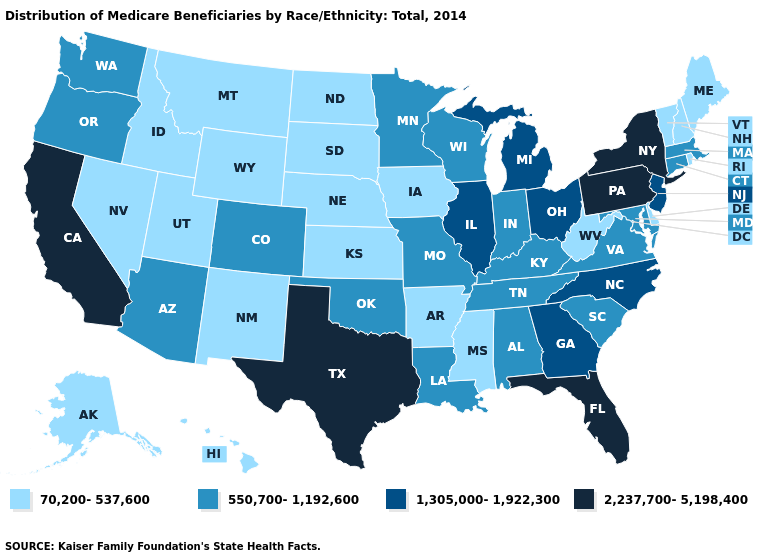Name the states that have a value in the range 70,200-537,600?
Give a very brief answer. Alaska, Arkansas, Delaware, Hawaii, Idaho, Iowa, Kansas, Maine, Mississippi, Montana, Nebraska, Nevada, New Hampshire, New Mexico, North Dakota, Rhode Island, South Dakota, Utah, Vermont, West Virginia, Wyoming. What is the value of Connecticut?
Short answer required. 550,700-1,192,600. Name the states that have a value in the range 1,305,000-1,922,300?
Give a very brief answer. Georgia, Illinois, Michigan, New Jersey, North Carolina, Ohio. What is the lowest value in the USA?
Concise answer only. 70,200-537,600. What is the value of Pennsylvania?
Write a very short answer. 2,237,700-5,198,400. Among the states that border Minnesota , which have the lowest value?
Keep it brief. Iowa, North Dakota, South Dakota. Among the states that border Montana , which have the highest value?
Give a very brief answer. Idaho, North Dakota, South Dakota, Wyoming. What is the value of Pennsylvania?
Write a very short answer. 2,237,700-5,198,400. Name the states that have a value in the range 2,237,700-5,198,400?
Give a very brief answer. California, Florida, New York, Pennsylvania, Texas. Name the states that have a value in the range 70,200-537,600?
Be succinct. Alaska, Arkansas, Delaware, Hawaii, Idaho, Iowa, Kansas, Maine, Mississippi, Montana, Nebraska, Nevada, New Hampshire, New Mexico, North Dakota, Rhode Island, South Dakota, Utah, Vermont, West Virginia, Wyoming. Is the legend a continuous bar?
Write a very short answer. No. How many symbols are there in the legend?
Give a very brief answer. 4. Which states have the highest value in the USA?
Be succinct. California, Florida, New York, Pennsylvania, Texas. What is the highest value in states that border Maine?
Concise answer only. 70,200-537,600. 